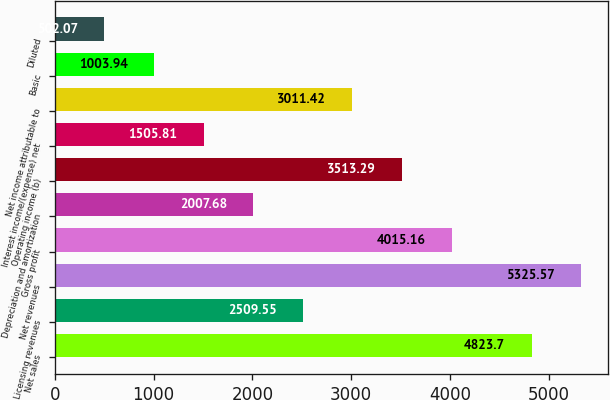<chart> <loc_0><loc_0><loc_500><loc_500><bar_chart><fcel>Net sales<fcel>Licensing revenues<fcel>Net revenues<fcel>Gross profit<fcel>Depreciation and amortization<fcel>Operating income (b)<fcel>Interest income/(expense) net<fcel>Net income attributable to<fcel>Basic<fcel>Diluted<nl><fcel>4823.7<fcel>2509.55<fcel>5325.57<fcel>4015.16<fcel>2007.68<fcel>3513.29<fcel>1505.81<fcel>3011.42<fcel>1003.94<fcel>502.07<nl></chart> 